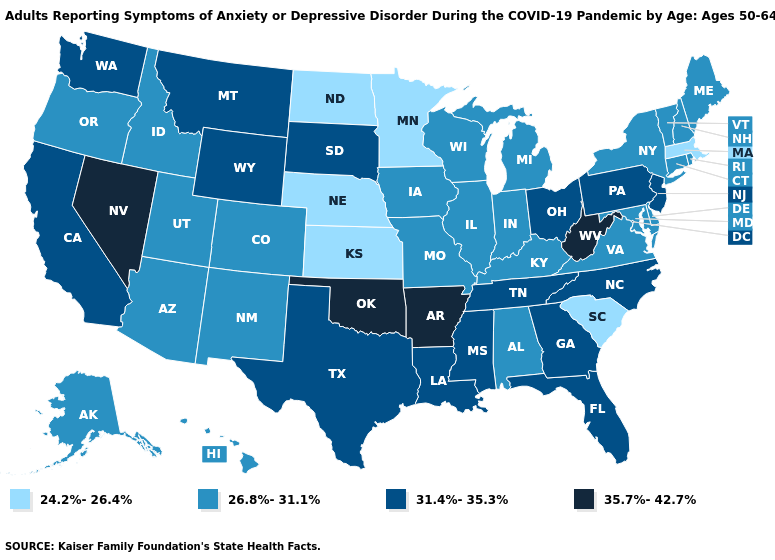Name the states that have a value in the range 35.7%-42.7%?
Be succinct. Arkansas, Nevada, Oklahoma, West Virginia. What is the value of Connecticut?
Give a very brief answer. 26.8%-31.1%. Is the legend a continuous bar?
Quick response, please. No. Does Mississippi have the highest value in the USA?
Write a very short answer. No. Name the states that have a value in the range 24.2%-26.4%?
Short answer required. Kansas, Massachusetts, Minnesota, Nebraska, North Dakota, South Carolina. Which states have the highest value in the USA?
Keep it brief. Arkansas, Nevada, Oklahoma, West Virginia. What is the value of Montana?
Give a very brief answer. 31.4%-35.3%. Name the states that have a value in the range 35.7%-42.7%?
Answer briefly. Arkansas, Nevada, Oklahoma, West Virginia. Among the states that border Delaware , does Maryland have the highest value?
Be succinct. No. Does Missouri have the lowest value in the MidWest?
Be succinct. No. Which states have the highest value in the USA?
Keep it brief. Arkansas, Nevada, Oklahoma, West Virginia. Among the states that border Wisconsin , which have the lowest value?
Be succinct. Minnesota. Which states have the highest value in the USA?
Short answer required. Arkansas, Nevada, Oklahoma, West Virginia. Does Nevada have the highest value in the USA?
Write a very short answer. Yes. 